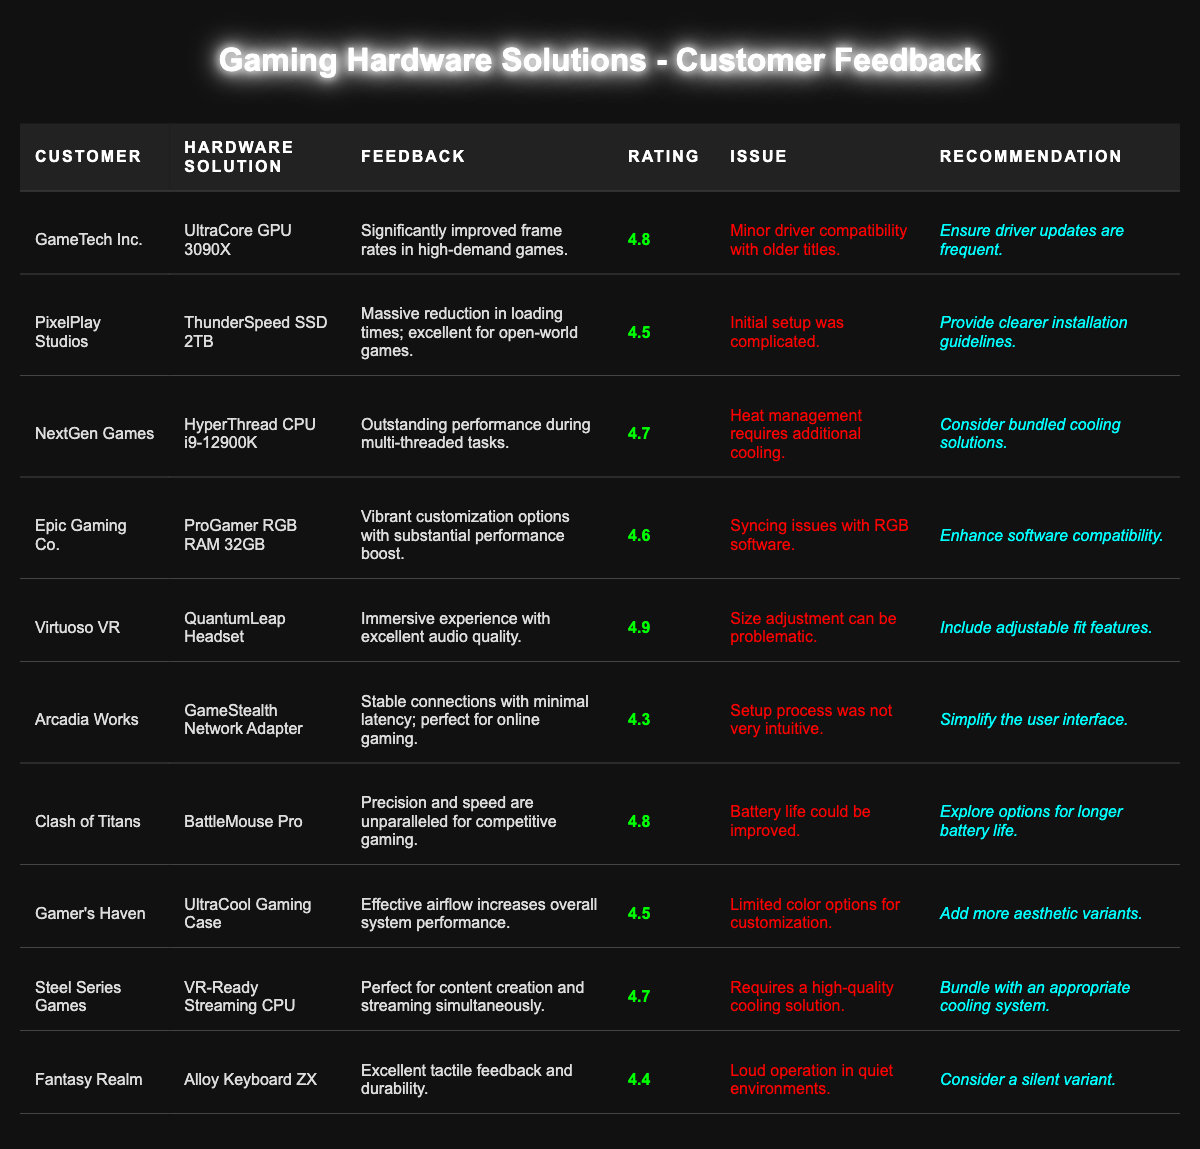What is the highest-rated hardware solution? The highest rating in the table is 4.9 for the "QuantumLeap Headset" from "Virtuoso VR."
Answer: QuantumLeap Headset How many hardware solutions received a rating of 4.7 or higher? The solutions with ratings of 4.7 or higher are 5: UltraCore GPU 3090X, HyperThread CPU i9-12900K, ProGamer RGB RAM 32GB, QuantumLeap Headset, and VR-Ready Streaming CPU.
Answer: 5 What recommendation was given for the GameStealth Network Adapter? The recommendation is to "Simplify the user interface." referring to the setup process.
Answer: Simplify the user interface Is there a customer that reported an issue with battery life? Yes, "Clash of Titans" reported that the "BattleMouse Pro" has a battery life that could be improved.
Answer: Yes Which hardware solution had issues related to software compatibility? The "ProGamer RGB RAM 32GB" experienced syncing issues with RGB software.
Answer: ProGamer RGB RAM 32GB What is the average rating of the hardware solutions listed? The average rating is calculated as (4.8 + 4.5 + 4.7 + 4.6 + 4.9 + 4.3 + 4.8 + 4.5 + 4.7 + 4.4) / 10 = 4.57.
Answer: 4.57 Which customer purchased the fastest loading time solution? "PixelPlay Studios" purchased the "ThunderSpeed SSD 2TB," which reportedly decreased loading times.
Answer: PixelPlay Studios What issue did "Virtuoso VR" report about the QuantumLeap Headset? They reported that size adjustment can be problematic, which affects the fit.
Answer: Size adjustment issues How does the performance of the BattleMouse Pro compare to others? The BattleMouse Pro has unparalleled precision and speed, rated at 4.8, which is high among the solutions.
Answer: High performance What percentages of the solutions had an issue related to setup or installation? 3 out of 10 solutions had issues with setup or installation (PixelPlay Studios, Arcadia Works, Clash of Titans), so the percentage is (3/10) * 100 = 30%.
Answer: 30% 